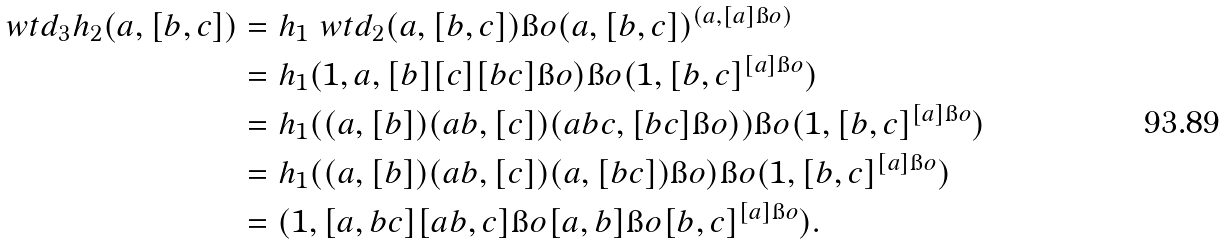<formula> <loc_0><loc_0><loc_500><loc_500>\ w t d _ { 3 } h _ { 2 } ( a , [ b , c ] ) & = h _ { 1 } \ w t d _ { 2 } ( a , [ b , c ] ) \i o ( a , [ b , c ] ) ^ { ( a , [ a ] \i o ) } \\ & = h _ { 1 } ( 1 , a , [ b ] [ c ] [ b c ] \i o ) \i o ( 1 , [ b , c ] ^ { [ a ] \i o } ) \\ & = h _ { 1 } ( ( a , [ b ] ) ( a b , [ c ] ) ( a b c , [ b c ] \i o ) ) \i o ( 1 , [ b , c ] ^ { [ a ] \i o } ) \\ & = h _ { 1 } ( ( a , [ b ] ) ( a b , [ c ] ) ( a , [ b c ] ) \i o ) \i o ( 1 , [ b , c ] ^ { [ a ] \i o } ) \\ & = ( 1 , [ a , b c ] [ a b , c ] \i o [ a , b ] \i o [ b , c ] ^ { [ a ] \i o } ) .</formula> 